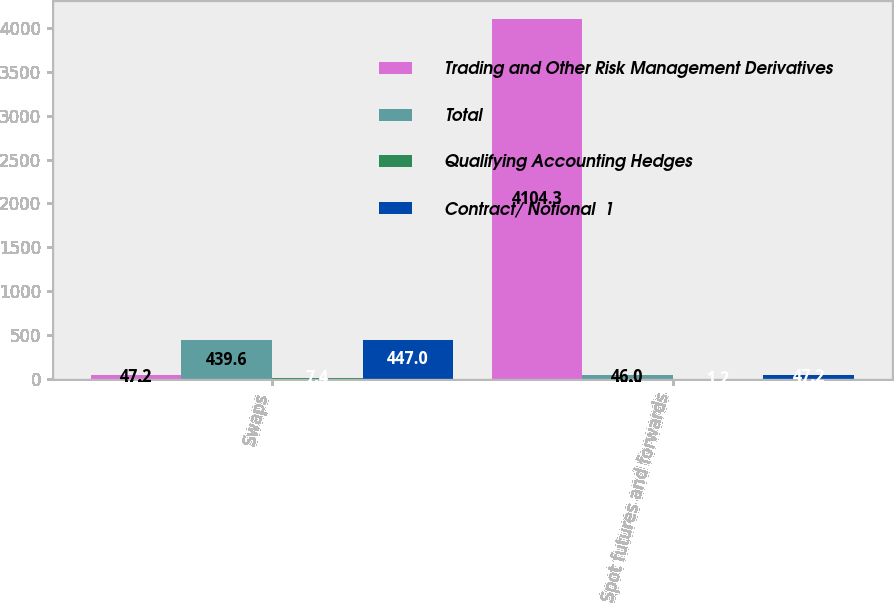Convert chart to OTSL. <chart><loc_0><loc_0><loc_500><loc_500><stacked_bar_chart><ecel><fcel>Swaps<fcel>Spot futures and forwards<nl><fcel>Trading and Other Risk Management Derivatives<fcel>47.2<fcel>4104.3<nl><fcel>Total<fcel>439.6<fcel>46<nl><fcel>Qualifying Accounting Hedges<fcel>7.4<fcel>1.2<nl><fcel>Contract/ Notional  1<fcel>447<fcel>47.2<nl></chart> 